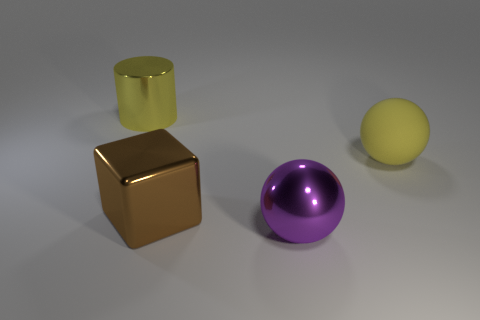How many objects are in the image, and can you describe their shapes? There are four objects in the image: a large yellow cylinder, a large bronze cube, a large purple ball, and a smaller yellow ball. The cylinder and cube have defined edges, while the balls are spherical. 